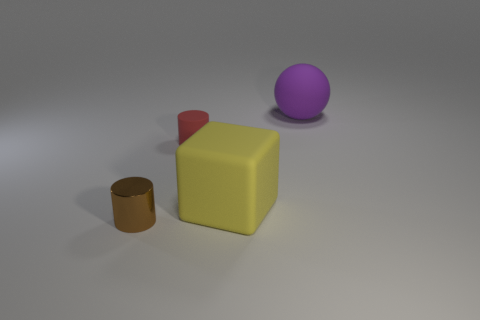What number of objects are large things to the left of the big purple rubber sphere or things that are to the left of the yellow rubber block?
Provide a short and direct response. 3. There is a matte object in front of the small cylinder behind the brown shiny thing; what is its size?
Provide a succinct answer. Large. What size is the brown thing?
Ensure brevity in your answer.  Small. How many other objects are the same material as the purple sphere?
Provide a succinct answer. 2. Are any tiny blocks visible?
Your answer should be very brief. No. Is the material of the cylinder that is behind the yellow block the same as the big purple object?
Keep it short and to the point. Yes. What material is the tiny brown object that is the same shape as the red object?
Offer a very short reply. Metal. Is the number of rubber blocks less than the number of cylinders?
Your answer should be compact. Yes. There is a big thing that is the same material as the cube; what is its color?
Offer a terse response. Purple. Is the size of the purple thing the same as the matte block?
Provide a short and direct response. Yes. 